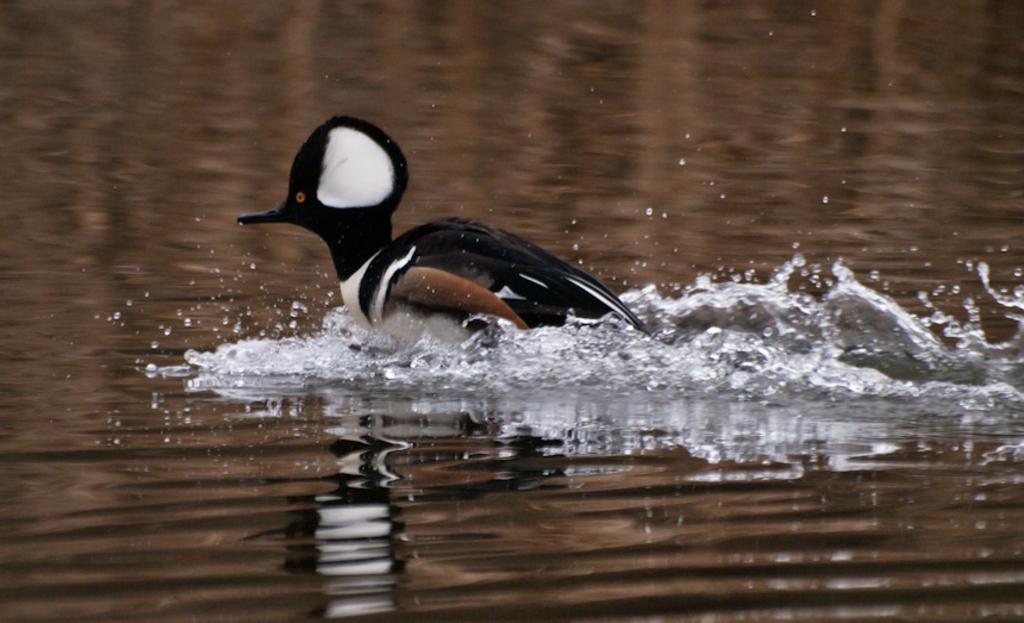How would you summarize this image in a sentence or two? In this image I see a bird which is off white, black and brown in color and I see the water. 